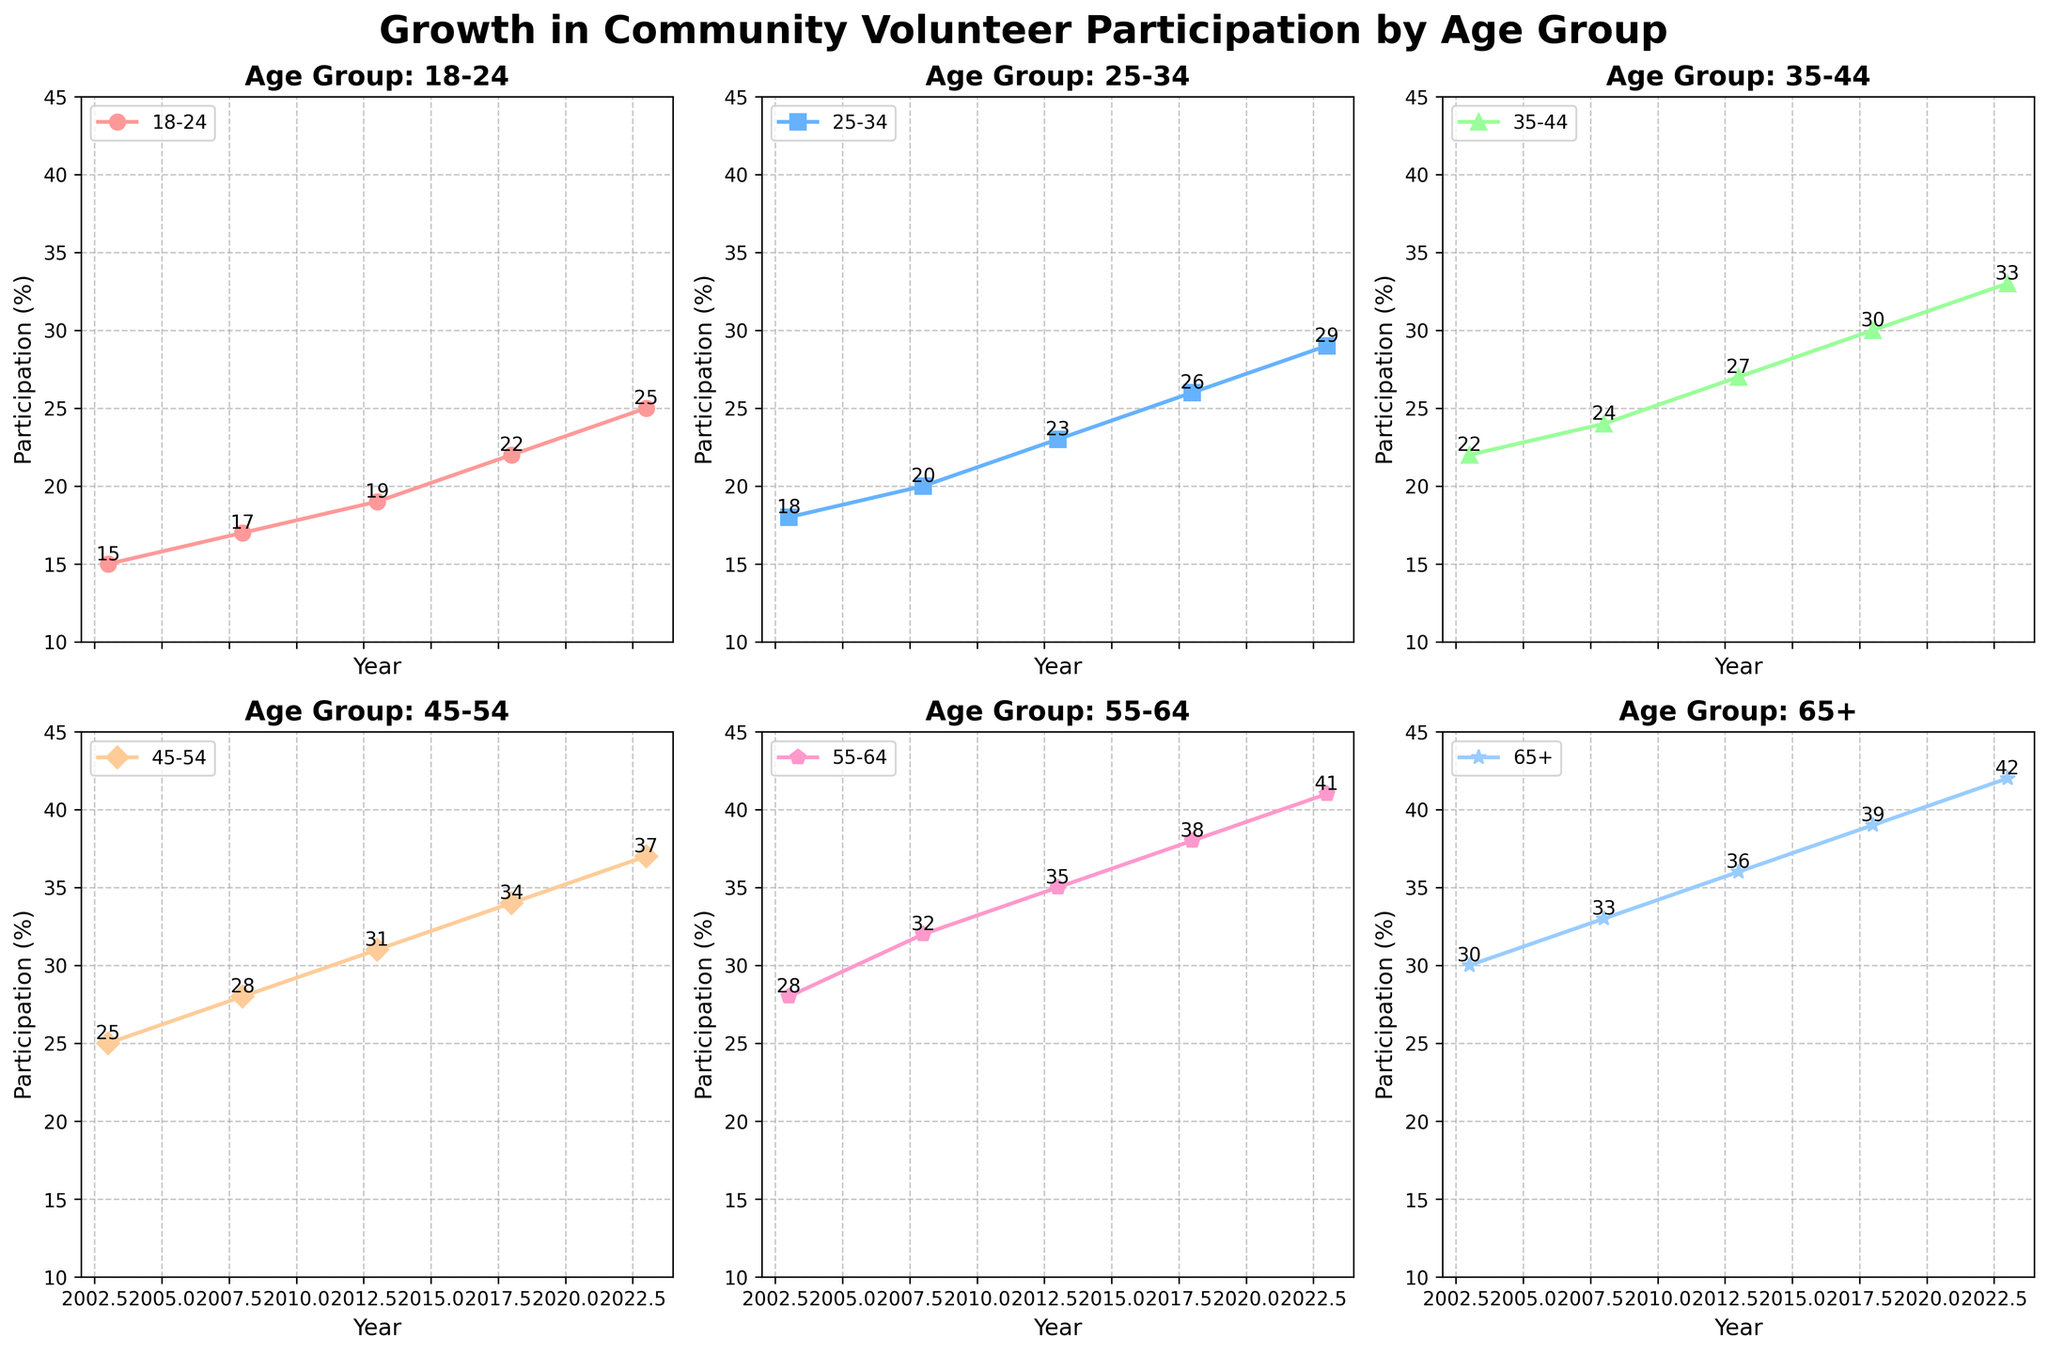What is the title of the figure? The title is at the top of the figure and reads "Growth in Community Volunteer Participation by Age Group".
Answer: Growth in Community Volunteer Participation by Age Group How many subplots are there in the figure? There are 2 rows and 3 columns of subplots, which means a total of 6 subplots.
Answer: 6 Which age group had the highest participation in 2023? From the subplot for each age group, the data point for the year 2023 is the highest for the 65+ age group.
Answer: 65+ Which age group showed the greatest increase in participation between 2003 and 2023? To find the greatest increase, subtract the 2003 value from the 2023 value for each age group: 
(25-15) for 18-24, (29-18) for 25-34, (33-22) for 35-44, (37-25) for 45-54, (41-28) for 55-64, and (42-30) for 65+. 
The 55-64 group had the highest increase: 41 - 28 = 13.
Answer: 55-64 What was the participation percentage for the 35-44 age group in 2013? Locate the subplot for the 35-44 age group and find the data point for the year 2013, which is 27%.
Answer: 27% Which age group had a participation percentage closest to 35% in any year shown on the chart? The 35% participation value is listed for the 55-64 age group in 2013.
Answer: 55-64 How did the participation change for the 18-24 age group from 2003 to 2023? Look at the subplot for 18-24 and note the values for 2003 (15%) and 2023 (25%). The change is: 25 - 15 = 10%.
Answer: Increased by 10% In what year did the 45-54 age group surpass a participation rate of 30%? Check the 45-54 subplot. The first year where the value is above 30% is 2013 (31%).
Answer: 2013 How do the participation trends of the 25-34 and 55-64 age groups compare from 2003 to 2023? The 25-34 age group starts at 18% in 2003 and ends at 29% in 2023, while the 55-64 age group starts at 28% in 2003 and ends at 41% in 2023. Both show an increasing trend, but the 55-64 age group shows a larger absolute increase (13% compared to 11%).
Answer: Both increased, but 55-64 showed a larger increase 